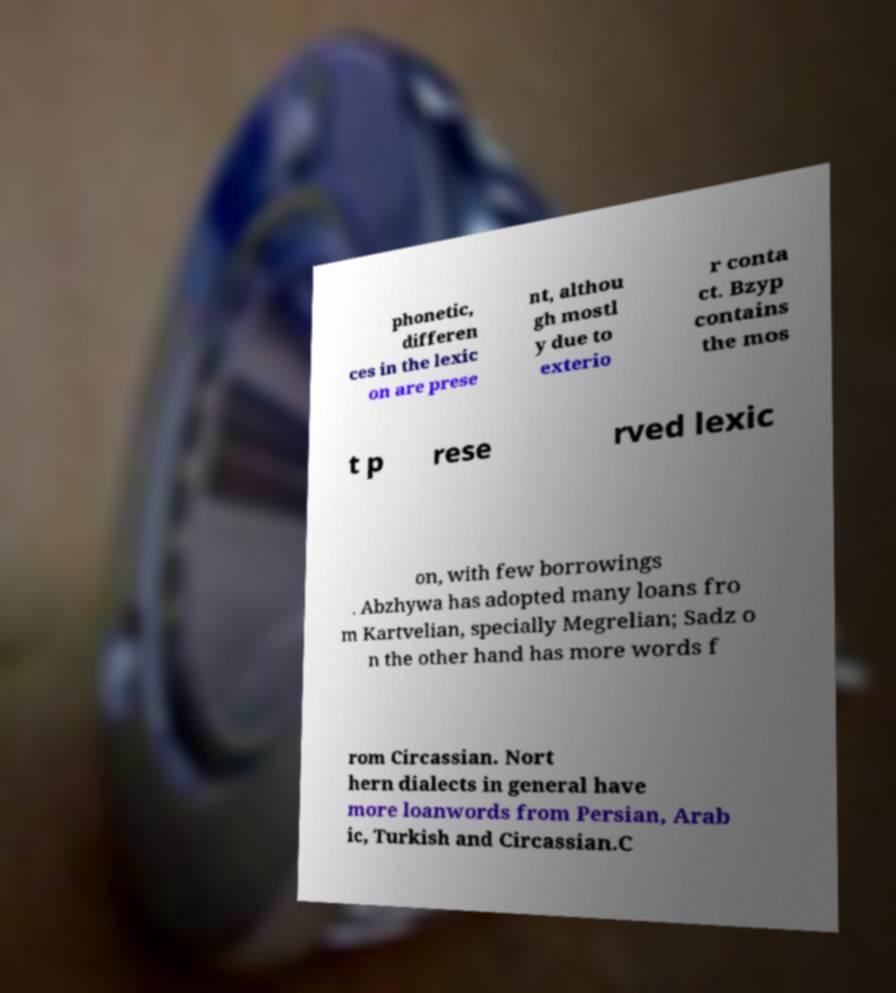Can you read and provide the text displayed in the image?This photo seems to have some interesting text. Can you extract and type it out for me? phonetic, differen ces in the lexic on are prese nt, althou gh mostl y due to exterio r conta ct. Bzyp contains the mos t p rese rved lexic on, with few borrowings . Abzhywa has adopted many loans fro m Kartvelian, specially Megrelian; Sadz o n the other hand has more words f rom Circassian. Nort hern dialects in general have more loanwords from Persian, Arab ic, Turkish and Circassian.C 